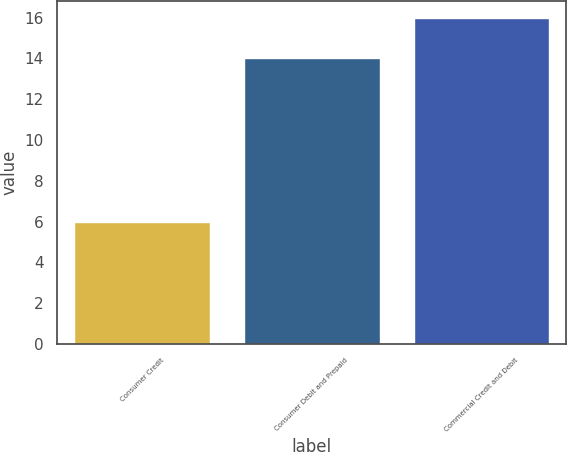Convert chart to OTSL. <chart><loc_0><loc_0><loc_500><loc_500><bar_chart><fcel>Consumer Credit<fcel>Consumer Debit and Prepaid<fcel>Commercial Credit and Debit<nl><fcel>6<fcel>14<fcel>16<nl></chart> 